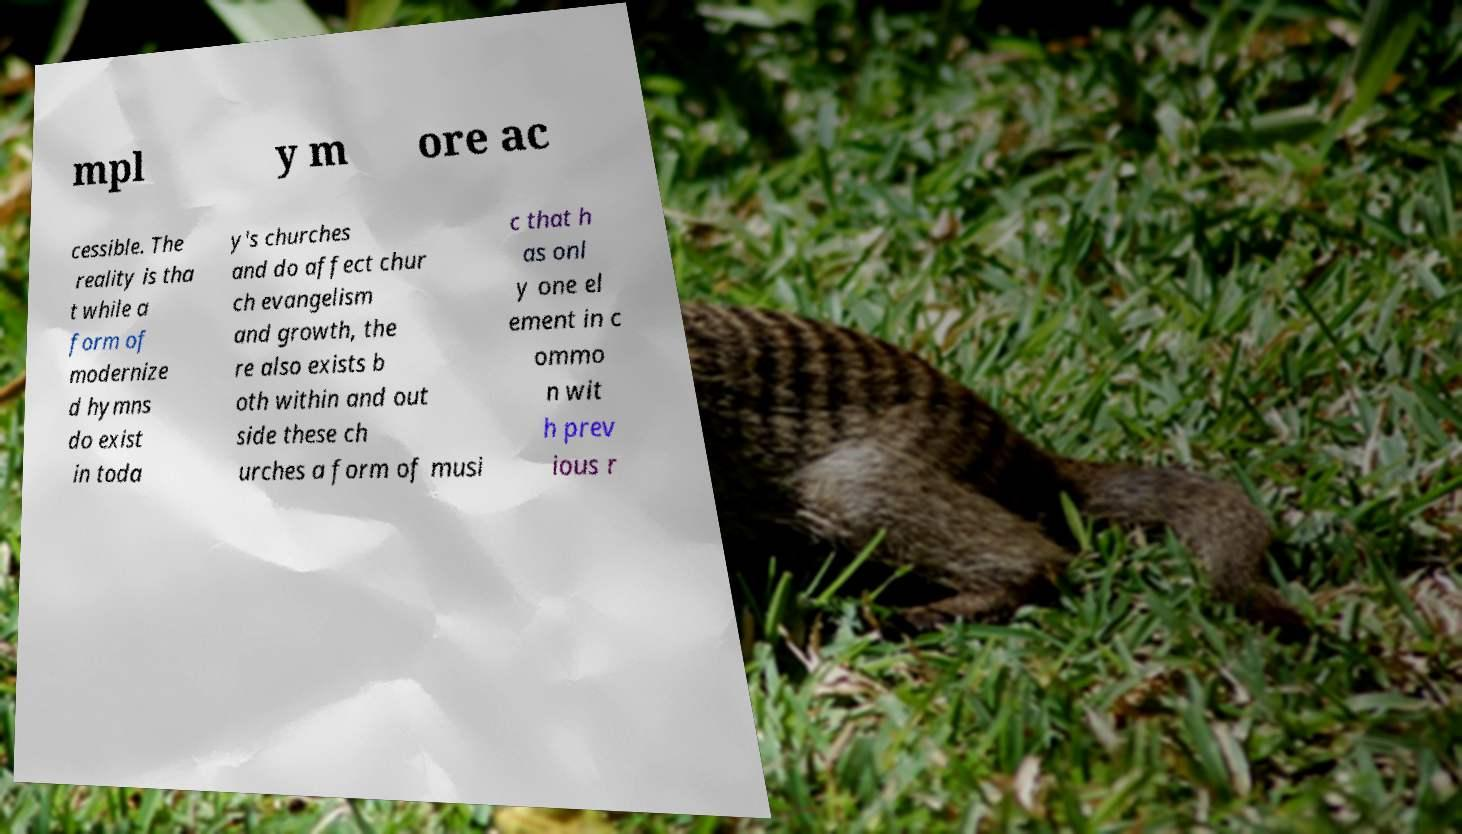Please read and relay the text visible in this image. What does it say? mpl y m ore ac cessible. The reality is tha t while a form of modernize d hymns do exist in toda y's churches and do affect chur ch evangelism and growth, the re also exists b oth within and out side these ch urches a form of musi c that h as onl y one el ement in c ommo n wit h prev ious r 